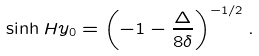<formula> <loc_0><loc_0><loc_500><loc_500>\sinh H y _ { 0 } = \left ( - 1 - \frac { \Delta } { 8 \delta } \right ) ^ { - 1 / 2 } .</formula> 